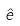<formula> <loc_0><loc_0><loc_500><loc_500>\hat { e }</formula> 